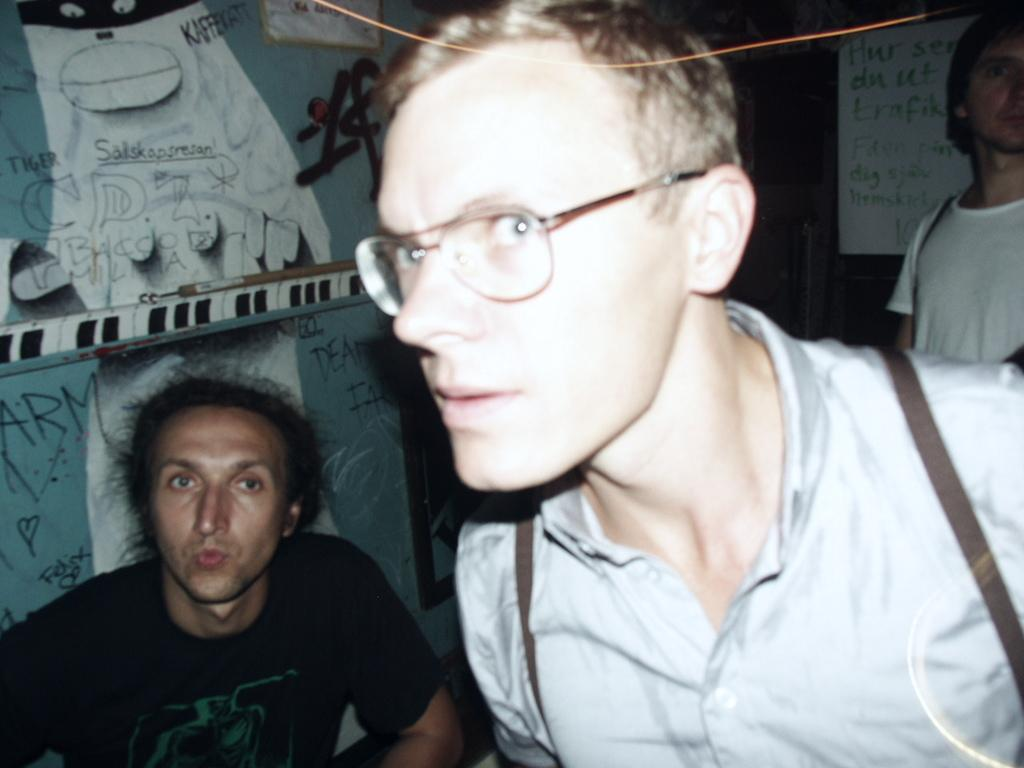Who or what can be seen in the image? There are people in the image. Can you describe the background of the image? There are boards placed on a wall in the background of the image. How many pies are displayed on the calendar in the image? There are no pies or calendars present in the image. What type of ornament is hanging from the boards in the image? There is no ornament hanging from the boards in the image; only the boards are mentioned. 